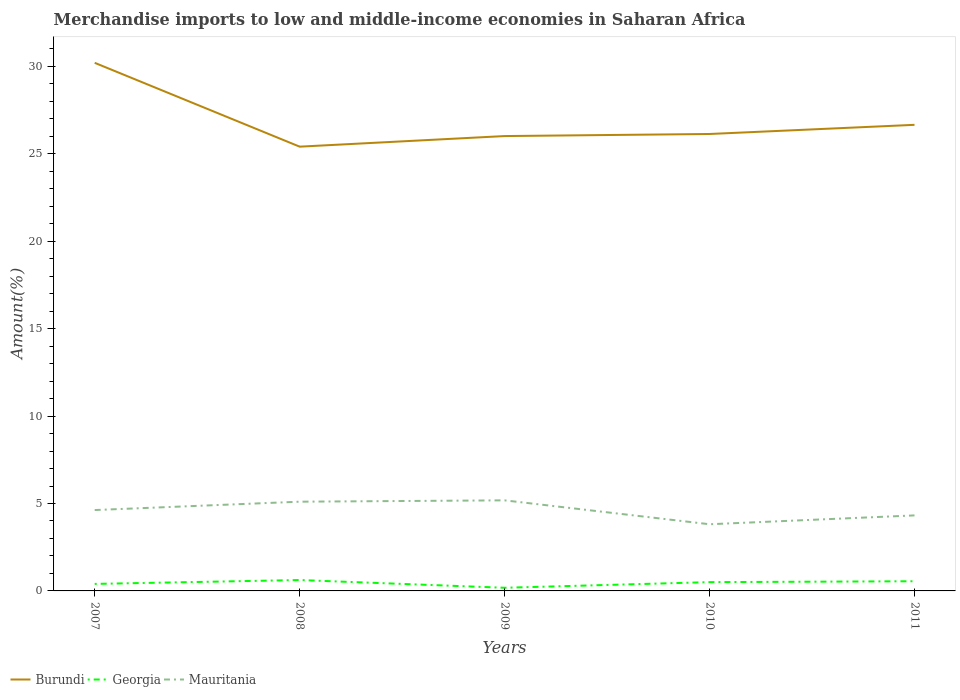How many different coloured lines are there?
Your answer should be compact. 3. Is the number of lines equal to the number of legend labels?
Your response must be concise. Yes. Across all years, what is the maximum percentage of amount earned from merchandise imports in Georgia?
Offer a very short reply. 0.18. In which year was the percentage of amount earned from merchandise imports in Georgia maximum?
Keep it short and to the point. 2009. What is the total percentage of amount earned from merchandise imports in Mauritania in the graph?
Give a very brief answer. -0.55. What is the difference between the highest and the second highest percentage of amount earned from merchandise imports in Burundi?
Your answer should be very brief. 4.79. Is the percentage of amount earned from merchandise imports in Georgia strictly greater than the percentage of amount earned from merchandise imports in Burundi over the years?
Provide a short and direct response. Yes. What is the difference between two consecutive major ticks on the Y-axis?
Provide a succinct answer. 5. Does the graph contain any zero values?
Offer a terse response. No. What is the title of the graph?
Keep it short and to the point. Merchandise imports to low and middle-income economies in Saharan Africa. Does "Denmark" appear as one of the legend labels in the graph?
Your answer should be compact. No. What is the label or title of the X-axis?
Ensure brevity in your answer.  Years. What is the label or title of the Y-axis?
Offer a very short reply. Amount(%). What is the Amount(%) in Burundi in 2007?
Make the answer very short. 30.2. What is the Amount(%) of Georgia in 2007?
Provide a short and direct response. 0.4. What is the Amount(%) of Mauritania in 2007?
Your answer should be very brief. 4.63. What is the Amount(%) of Burundi in 2008?
Keep it short and to the point. 25.41. What is the Amount(%) in Georgia in 2008?
Provide a succinct answer. 0.62. What is the Amount(%) in Mauritania in 2008?
Offer a terse response. 5.1. What is the Amount(%) in Burundi in 2009?
Offer a very short reply. 26.01. What is the Amount(%) in Georgia in 2009?
Ensure brevity in your answer.  0.18. What is the Amount(%) of Mauritania in 2009?
Ensure brevity in your answer.  5.18. What is the Amount(%) in Burundi in 2010?
Provide a succinct answer. 26.13. What is the Amount(%) of Georgia in 2010?
Your answer should be compact. 0.5. What is the Amount(%) of Mauritania in 2010?
Ensure brevity in your answer.  3.81. What is the Amount(%) of Burundi in 2011?
Provide a short and direct response. 26.66. What is the Amount(%) of Georgia in 2011?
Keep it short and to the point. 0.55. What is the Amount(%) of Mauritania in 2011?
Your answer should be compact. 4.32. Across all years, what is the maximum Amount(%) of Burundi?
Provide a succinct answer. 30.2. Across all years, what is the maximum Amount(%) in Georgia?
Give a very brief answer. 0.62. Across all years, what is the maximum Amount(%) in Mauritania?
Give a very brief answer. 5.18. Across all years, what is the minimum Amount(%) in Burundi?
Make the answer very short. 25.41. Across all years, what is the minimum Amount(%) in Georgia?
Your answer should be compact. 0.18. Across all years, what is the minimum Amount(%) in Mauritania?
Offer a terse response. 3.81. What is the total Amount(%) of Burundi in the graph?
Make the answer very short. 134.41. What is the total Amount(%) in Georgia in the graph?
Offer a very short reply. 2.26. What is the total Amount(%) in Mauritania in the graph?
Ensure brevity in your answer.  23.04. What is the difference between the Amount(%) in Burundi in 2007 and that in 2008?
Your answer should be very brief. 4.79. What is the difference between the Amount(%) of Georgia in 2007 and that in 2008?
Offer a terse response. -0.22. What is the difference between the Amount(%) in Mauritania in 2007 and that in 2008?
Provide a short and direct response. -0.48. What is the difference between the Amount(%) in Burundi in 2007 and that in 2009?
Offer a terse response. 4.19. What is the difference between the Amount(%) in Georgia in 2007 and that in 2009?
Your response must be concise. 0.22. What is the difference between the Amount(%) of Mauritania in 2007 and that in 2009?
Provide a short and direct response. -0.56. What is the difference between the Amount(%) of Burundi in 2007 and that in 2010?
Your answer should be very brief. 4.07. What is the difference between the Amount(%) of Georgia in 2007 and that in 2010?
Provide a succinct answer. -0.1. What is the difference between the Amount(%) of Mauritania in 2007 and that in 2010?
Offer a very short reply. 0.81. What is the difference between the Amount(%) of Burundi in 2007 and that in 2011?
Offer a terse response. 3.55. What is the difference between the Amount(%) in Georgia in 2007 and that in 2011?
Offer a very short reply. -0.15. What is the difference between the Amount(%) in Mauritania in 2007 and that in 2011?
Your answer should be compact. 0.31. What is the difference between the Amount(%) of Burundi in 2008 and that in 2009?
Make the answer very short. -0.61. What is the difference between the Amount(%) in Georgia in 2008 and that in 2009?
Offer a very short reply. 0.44. What is the difference between the Amount(%) in Mauritania in 2008 and that in 2009?
Your answer should be very brief. -0.08. What is the difference between the Amount(%) of Burundi in 2008 and that in 2010?
Your answer should be very brief. -0.72. What is the difference between the Amount(%) in Georgia in 2008 and that in 2010?
Make the answer very short. 0.12. What is the difference between the Amount(%) of Mauritania in 2008 and that in 2010?
Your response must be concise. 1.29. What is the difference between the Amount(%) of Burundi in 2008 and that in 2011?
Offer a terse response. -1.25. What is the difference between the Amount(%) of Georgia in 2008 and that in 2011?
Your answer should be very brief. 0.07. What is the difference between the Amount(%) in Mauritania in 2008 and that in 2011?
Give a very brief answer. 0.78. What is the difference between the Amount(%) in Burundi in 2009 and that in 2010?
Give a very brief answer. -0.12. What is the difference between the Amount(%) of Georgia in 2009 and that in 2010?
Provide a short and direct response. -0.32. What is the difference between the Amount(%) in Mauritania in 2009 and that in 2010?
Provide a short and direct response. 1.37. What is the difference between the Amount(%) in Burundi in 2009 and that in 2011?
Provide a short and direct response. -0.64. What is the difference between the Amount(%) in Georgia in 2009 and that in 2011?
Make the answer very short. -0.37. What is the difference between the Amount(%) of Mauritania in 2009 and that in 2011?
Provide a short and direct response. 0.86. What is the difference between the Amount(%) of Burundi in 2010 and that in 2011?
Provide a short and direct response. -0.52. What is the difference between the Amount(%) of Georgia in 2010 and that in 2011?
Provide a short and direct response. -0.05. What is the difference between the Amount(%) of Mauritania in 2010 and that in 2011?
Your answer should be very brief. -0.51. What is the difference between the Amount(%) of Burundi in 2007 and the Amount(%) of Georgia in 2008?
Your answer should be very brief. 29.58. What is the difference between the Amount(%) in Burundi in 2007 and the Amount(%) in Mauritania in 2008?
Offer a very short reply. 25.1. What is the difference between the Amount(%) of Georgia in 2007 and the Amount(%) of Mauritania in 2008?
Ensure brevity in your answer.  -4.7. What is the difference between the Amount(%) in Burundi in 2007 and the Amount(%) in Georgia in 2009?
Make the answer very short. 30.02. What is the difference between the Amount(%) of Burundi in 2007 and the Amount(%) of Mauritania in 2009?
Your answer should be compact. 25.02. What is the difference between the Amount(%) in Georgia in 2007 and the Amount(%) in Mauritania in 2009?
Make the answer very short. -4.78. What is the difference between the Amount(%) in Burundi in 2007 and the Amount(%) in Georgia in 2010?
Provide a succinct answer. 29.7. What is the difference between the Amount(%) in Burundi in 2007 and the Amount(%) in Mauritania in 2010?
Ensure brevity in your answer.  26.39. What is the difference between the Amount(%) of Georgia in 2007 and the Amount(%) of Mauritania in 2010?
Ensure brevity in your answer.  -3.41. What is the difference between the Amount(%) in Burundi in 2007 and the Amount(%) in Georgia in 2011?
Ensure brevity in your answer.  29.65. What is the difference between the Amount(%) of Burundi in 2007 and the Amount(%) of Mauritania in 2011?
Give a very brief answer. 25.88. What is the difference between the Amount(%) in Georgia in 2007 and the Amount(%) in Mauritania in 2011?
Your answer should be compact. -3.92. What is the difference between the Amount(%) of Burundi in 2008 and the Amount(%) of Georgia in 2009?
Your response must be concise. 25.23. What is the difference between the Amount(%) in Burundi in 2008 and the Amount(%) in Mauritania in 2009?
Your answer should be very brief. 20.23. What is the difference between the Amount(%) in Georgia in 2008 and the Amount(%) in Mauritania in 2009?
Your answer should be very brief. -4.56. What is the difference between the Amount(%) in Burundi in 2008 and the Amount(%) in Georgia in 2010?
Offer a very short reply. 24.9. What is the difference between the Amount(%) in Burundi in 2008 and the Amount(%) in Mauritania in 2010?
Keep it short and to the point. 21.59. What is the difference between the Amount(%) of Georgia in 2008 and the Amount(%) of Mauritania in 2010?
Keep it short and to the point. -3.19. What is the difference between the Amount(%) in Burundi in 2008 and the Amount(%) in Georgia in 2011?
Offer a terse response. 24.85. What is the difference between the Amount(%) in Burundi in 2008 and the Amount(%) in Mauritania in 2011?
Provide a short and direct response. 21.09. What is the difference between the Amount(%) of Georgia in 2008 and the Amount(%) of Mauritania in 2011?
Provide a succinct answer. -3.7. What is the difference between the Amount(%) in Burundi in 2009 and the Amount(%) in Georgia in 2010?
Keep it short and to the point. 25.51. What is the difference between the Amount(%) of Burundi in 2009 and the Amount(%) of Mauritania in 2010?
Your response must be concise. 22.2. What is the difference between the Amount(%) in Georgia in 2009 and the Amount(%) in Mauritania in 2010?
Keep it short and to the point. -3.63. What is the difference between the Amount(%) in Burundi in 2009 and the Amount(%) in Georgia in 2011?
Ensure brevity in your answer.  25.46. What is the difference between the Amount(%) in Burundi in 2009 and the Amount(%) in Mauritania in 2011?
Your response must be concise. 21.69. What is the difference between the Amount(%) in Georgia in 2009 and the Amount(%) in Mauritania in 2011?
Give a very brief answer. -4.14. What is the difference between the Amount(%) of Burundi in 2010 and the Amount(%) of Georgia in 2011?
Give a very brief answer. 25.58. What is the difference between the Amount(%) in Burundi in 2010 and the Amount(%) in Mauritania in 2011?
Your answer should be compact. 21.81. What is the difference between the Amount(%) of Georgia in 2010 and the Amount(%) of Mauritania in 2011?
Offer a very short reply. -3.82. What is the average Amount(%) in Burundi per year?
Your answer should be very brief. 26.88. What is the average Amount(%) of Georgia per year?
Make the answer very short. 0.45. What is the average Amount(%) in Mauritania per year?
Provide a short and direct response. 4.61. In the year 2007, what is the difference between the Amount(%) in Burundi and Amount(%) in Georgia?
Your answer should be very brief. 29.8. In the year 2007, what is the difference between the Amount(%) in Burundi and Amount(%) in Mauritania?
Make the answer very short. 25.58. In the year 2007, what is the difference between the Amount(%) in Georgia and Amount(%) in Mauritania?
Offer a terse response. -4.22. In the year 2008, what is the difference between the Amount(%) of Burundi and Amount(%) of Georgia?
Your response must be concise. 24.78. In the year 2008, what is the difference between the Amount(%) of Burundi and Amount(%) of Mauritania?
Your answer should be very brief. 20.3. In the year 2008, what is the difference between the Amount(%) of Georgia and Amount(%) of Mauritania?
Your response must be concise. -4.48. In the year 2009, what is the difference between the Amount(%) of Burundi and Amount(%) of Georgia?
Offer a very short reply. 25.83. In the year 2009, what is the difference between the Amount(%) of Burundi and Amount(%) of Mauritania?
Your response must be concise. 20.83. In the year 2009, what is the difference between the Amount(%) of Georgia and Amount(%) of Mauritania?
Provide a succinct answer. -5. In the year 2010, what is the difference between the Amount(%) in Burundi and Amount(%) in Georgia?
Keep it short and to the point. 25.63. In the year 2010, what is the difference between the Amount(%) of Burundi and Amount(%) of Mauritania?
Offer a very short reply. 22.32. In the year 2010, what is the difference between the Amount(%) of Georgia and Amount(%) of Mauritania?
Offer a very short reply. -3.31. In the year 2011, what is the difference between the Amount(%) in Burundi and Amount(%) in Georgia?
Provide a short and direct response. 26.1. In the year 2011, what is the difference between the Amount(%) in Burundi and Amount(%) in Mauritania?
Provide a short and direct response. 22.34. In the year 2011, what is the difference between the Amount(%) in Georgia and Amount(%) in Mauritania?
Give a very brief answer. -3.77. What is the ratio of the Amount(%) of Burundi in 2007 to that in 2008?
Your answer should be compact. 1.19. What is the ratio of the Amount(%) in Georgia in 2007 to that in 2008?
Give a very brief answer. 0.65. What is the ratio of the Amount(%) in Mauritania in 2007 to that in 2008?
Provide a succinct answer. 0.91. What is the ratio of the Amount(%) of Burundi in 2007 to that in 2009?
Your response must be concise. 1.16. What is the ratio of the Amount(%) in Georgia in 2007 to that in 2009?
Your answer should be very brief. 2.23. What is the ratio of the Amount(%) of Mauritania in 2007 to that in 2009?
Offer a terse response. 0.89. What is the ratio of the Amount(%) of Burundi in 2007 to that in 2010?
Offer a terse response. 1.16. What is the ratio of the Amount(%) of Georgia in 2007 to that in 2010?
Offer a very short reply. 0.8. What is the ratio of the Amount(%) of Mauritania in 2007 to that in 2010?
Give a very brief answer. 1.21. What is the ratio of the Amount(%) in Burundi in 2007 to that in 2011?
Your response must be concise. 1.13. What is the ratio of the Amount(%) in Georgia in 2007 to that in 2011?
Your answer should be very brief. 0.73. What is the ratio of the Amount(%) of Mauritania in 2007 to that in 2011?
Provide a succinct answer. 1.07. What is the ratio of the Amount(%) of Burundi in 2008 to that in 2009?
Your answer should be very brief. 0.98. What is the ratio of the Amount(%) in Georgia in 2008 to that in 2009?
Give a very brief answer. 3.45. What is the ratio of the Amount(%) in Mauritania in 2008 to that in 2009?
Your response must be concise. 0.99. What is the ratio of the Amount(%) of Burundi in 2008 to that in 2010?
Ensure brevity in your answer.  0.97. What is the ratio of the Amount(%) in Georgia in 2008 to that in 2010?
Keep it short and to the point. 1.24. What is the ratio of the Amount(%) in Mauritania in 2008 to that in 2010?
Offer a very short reply. 1.34. What is the ratio of the Amount(%) of Burundi in 2008 to that in 2011?
Your answer should be very brief. 0.95. What is the ratio of the Amount(%) of Georgia in 2008 to that in 2011?
Provide a succinct answer. 1.12. What is the ratio of the Amount(%) in Mauritania in 2008 to that in 2011?
Your answer should be compact. 1.18. What is the ratio of the Amount(%) of Georgia in 2009 to that in 2010?
Give a very brief answer. 0.36. What is the ratio of the Amount(%) of Mauritania in 2009 to that in 2010?
Provide a short and direct response. 1.36. What is the ratio of the Amount(%) in Burundi in 2009 to that in 2011?
Ensure brevity in your answer.  0.98. What is the ratio of the Amount(%) in Georgia in 2009 to that in 2011?
Your answer should be very brief. 0.33. What is the ratio of the Amount(%) of Mauritania in 2009 to that in 2011?
Ensure brevity in your answer.  1.2. What is the ratio of the Amount(%) of Burundi in 2010 to that in 2011?
Provide a succinct answer. 0.98. What is the ratio of the Amount(%) in Georgia in 2010 to that in 2011?
Offer a terse response. 0.91. What is the ratio of the Amount(%) in Mauritania in 2010 to that in 2011?
Your response must be concise. 0.88. What is the difference between the highest and the second highest Amount(%) in Burundi?
Give a very brief answer. 3.55. What is the difference between the highest and the second highest Amount(%) of Georgia?
Offer a terse response. 0.07. What is the difference between the highest and the second highest Amount(%) of Mauritania?
Ensure brevity in your answer.  0.08. What is the difference between the highest and the lowest Amount(%) of Burundi?
Your answer should be compact. 4.79. What is the difference between the highest and the lowest Amount(%) in Georgia?
Make the answer very short. 0.44. What is the difference between the highest and the lowest Amount(%) of Mauritania?
Keep it short and to the point. 1.37. 